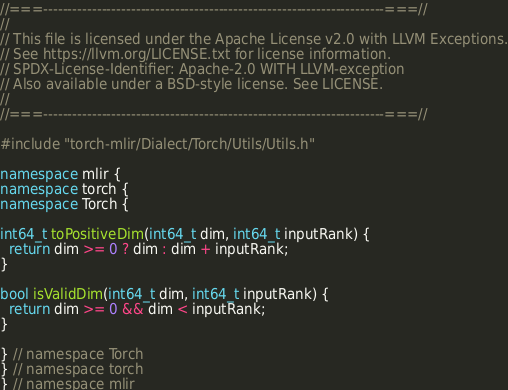<code> <loc_0><loc_0><loc_500><loc_500><_C++_>//===----------------------------------------------------------------------===//
//
// This file is licensed under the Apache License v2.0 with LLVM Exceptions.
// See https://llvm.org/LICENSE.txt for license information.
// SPDX-License-Identifier: Apache-2.0 WITH LLVM-exception
// Also available under a BSD-style license. See LICENSE.
//
//===----------------------------------------------------------------------===//

#include "torch-mlir/Dialect/Torch/Utils/Utils.h"

namespace mlir {
namespace torch {
namespace Torch {

int64_t toPositiveDim(int64_t dim, int64_t inputRank) {
  return dim >= 0 ? dim : dim + inputRank;
}

bool isValidDim(int64_t dim, int64_t inputRank) {
  return dim >= 0 && dim < inputRank;
}

} // namespace Torch
} // namespace torch
} // namespace mlir
</code> 